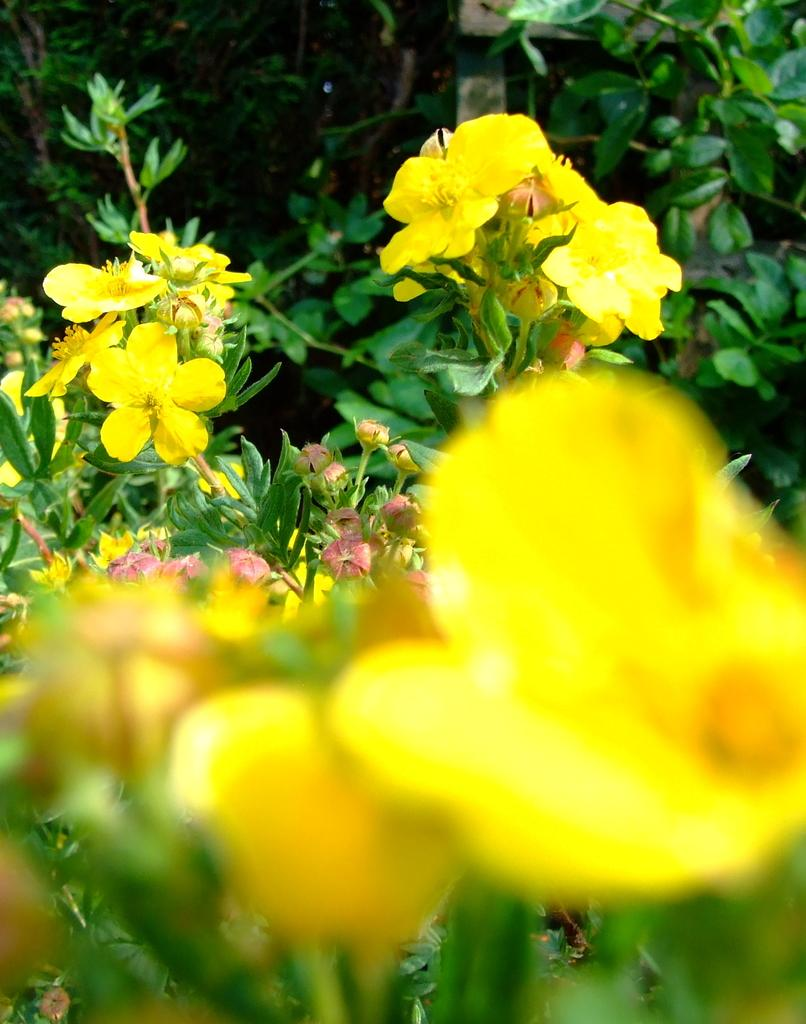What is the main subject of the image? The main subject of the image is many plants. What specific elements can be seen among the plants? There are flowers in the image. What colors are the flowers in the image? The flowers are in yellow and pink colors. How many babies are visible in the image? There are no babies present in the image; it features plants and flowers. What type of bird can be seen interacting with the flowers in the image? There is no bird, such as a wren, present in the image. 